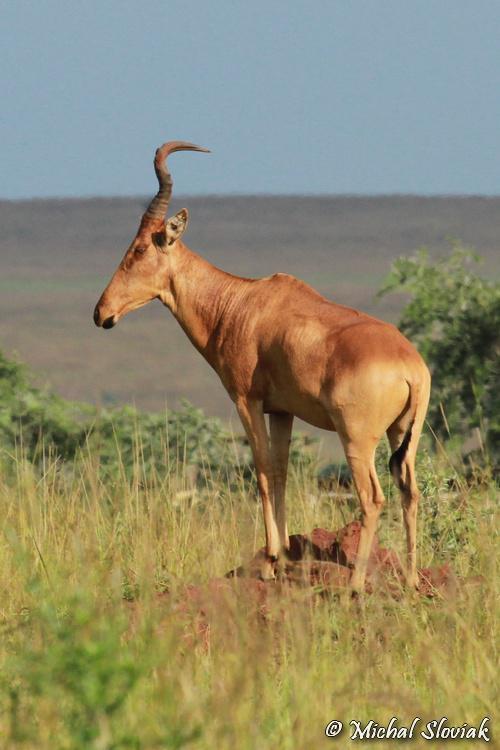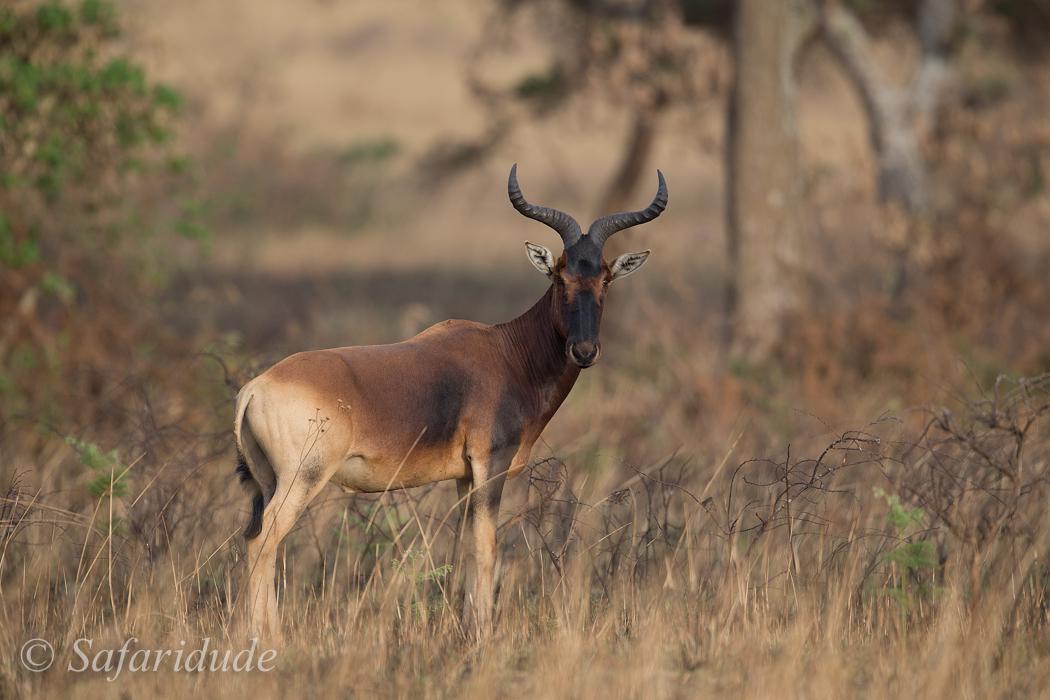The first image is the image on the left, the second image is the image on the right. For the images displayed, is the sentence "An image contains only one horned animal, which is standing with its head and body turned leftward." factually correct? Answer yes or no. Yes. The first image is the image on the left, the second image is the image on the right. For the images displayed, is the sentence "Two antelopes are facing the opposite direction than the other." factually correct? Answer yes or no. Yes. 